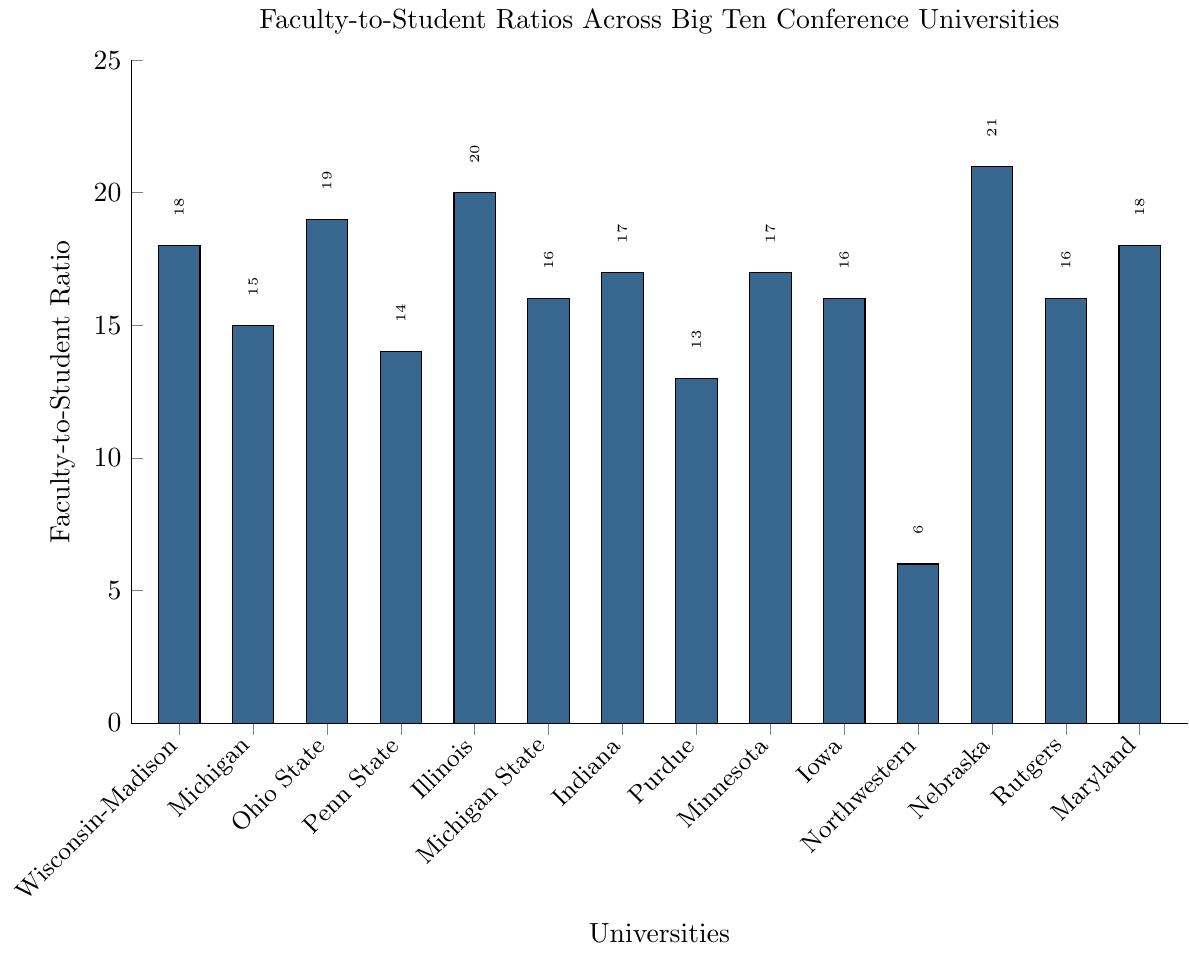Which university has the highest faculty-to-student ratio? The university with the highest bar on the plot represents the highest faculty-to-student ratio. Here, Nebraska has the highest bar at 21:1.
Answer: Nebraska Which university has the lowest faculty-to-student ratio? The lowest bar on the plot indicates the lowest faculty-to-student ratio. Northwestern University's bar is the shortest at 6:1.
Answer: Northwestern How many universities have a faculty-to-student ratio below 15? By examining the bars less than the 15 mark, we find that only Penn State (14) and Purdue (13) qualify.
Answer: 2 What's the difference in the faculty-to-student ratio between University of Wisconsin-Madison and Michigan State University? The ratio for Wisconsin-Madison is 18, and for Michigan State it's 16. The difference is 18 - 16 = 2.
Answer: 2 Which universities have the same faculty-to-student ratio? We observe the graph and note the heights of the bars. Michigan State, Iowa, and Rutgers all have a ratio of 16:1.
Answer: Michigan State, Iowa, Rutgers What is the total faculty-to-student ratio sum for Penn State, Purdue, and Northwestern universities? Add the ratios for Penn State (14), Purdue (13), and Northwestern (6). Sum = 14 + 13 + 6 = 33.
Answer: 33 Which university has a higher faculty-to-student ratio, University of Illinois or University of Michigan? Comparing the bars, Illinois has a ratio of 20, and Michigan has 15. 20 is greater than 15.
Answer: University of Illinois What is the average faculty-to-student ratio for the universities listed? Add all the ratios and divide by the number of universities. Sum = 18+15+19+14+20+16+17+13+17+16+6+21+16+18 = 226. Average = 226 / 14 = 16.14.
Answer: 16.14 What is the median faculty-to-student ratio for the universities? First, list the values in ascending order: 6, 13, 14, 15, 16, 16, 16, 17, 17, 18, 18, 19, 20, 21. With an even number of universities (14 in total), the median is the average of the 7th and 8th values: (16+17)/2 = 16.5.
Answer: 16.5 How does the faculty-to-student ratio for University of Maryland compare to University of Wisconsin-Madison? Both bars for Maryland and Wisconsin-Madison align at the 18 mark, indicating the same ratio.
Answer: They are equal 